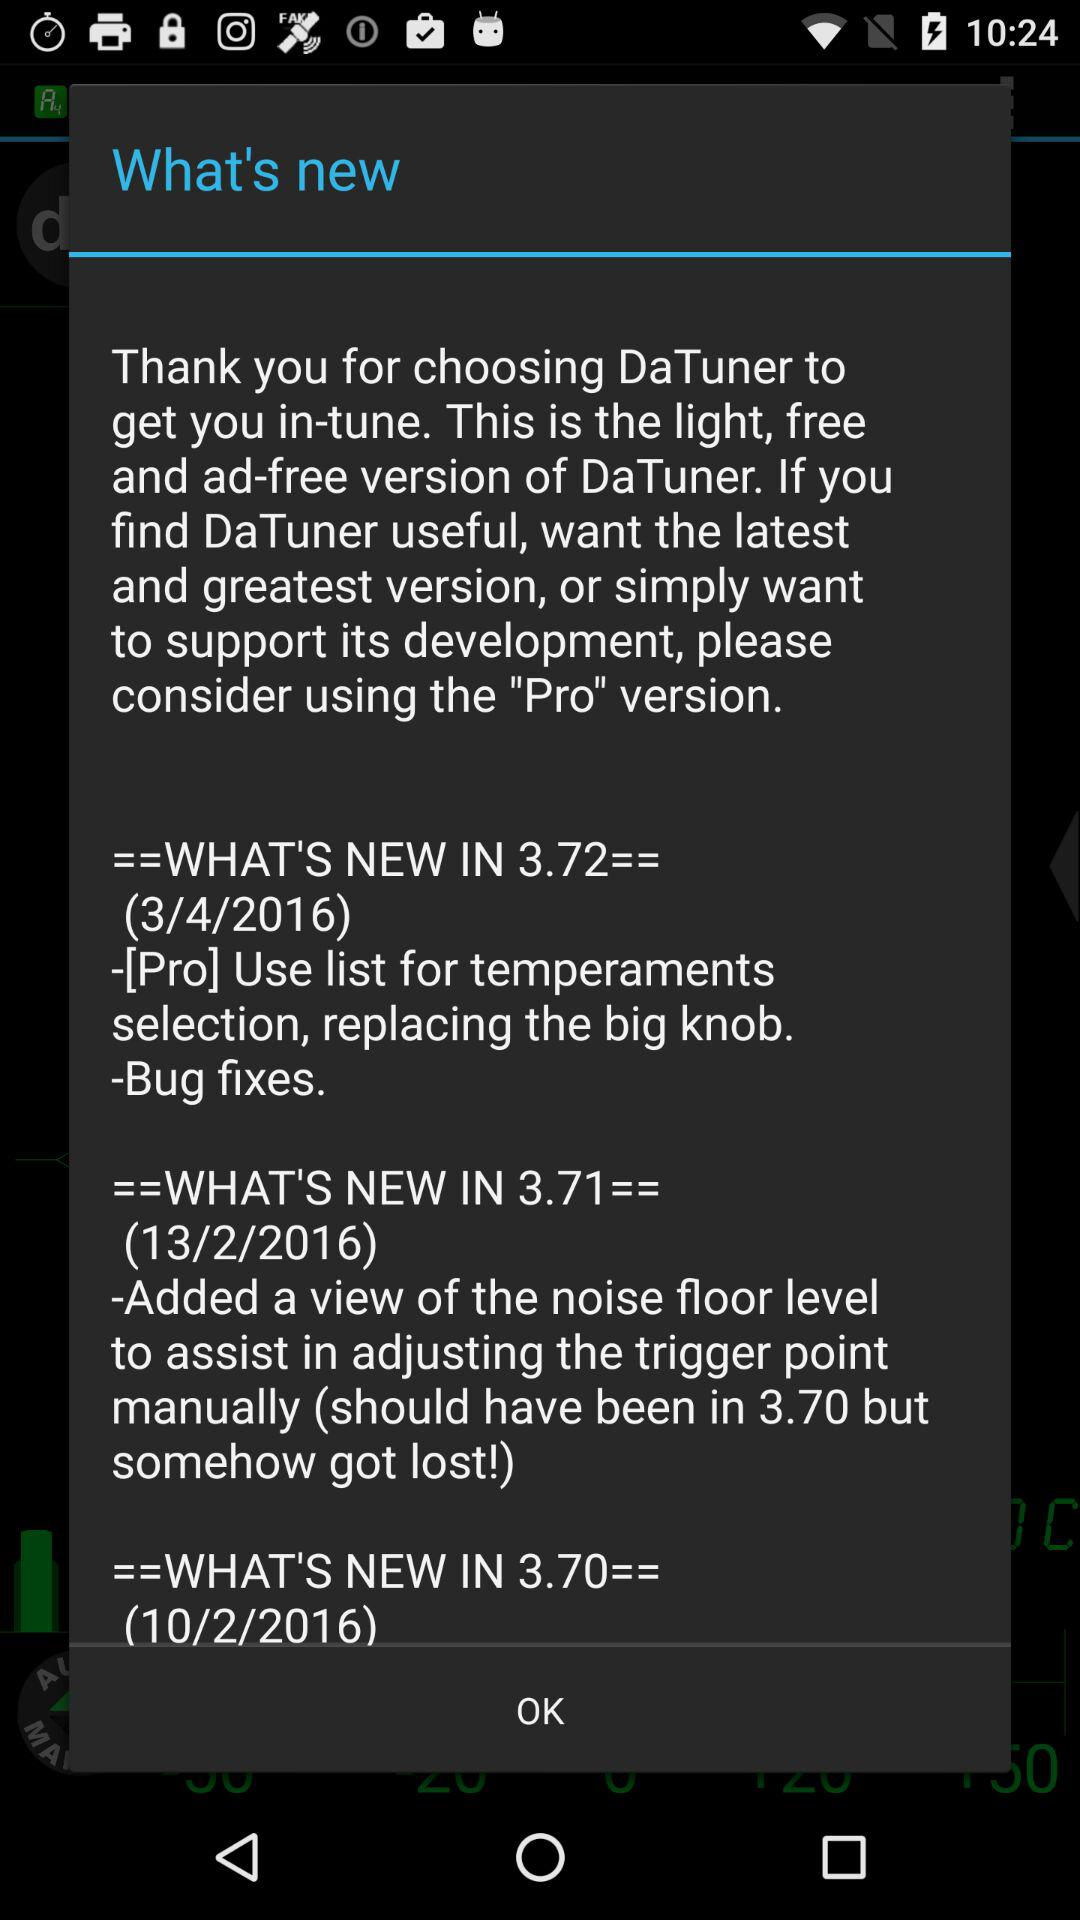What is the version of the application? The versions of the application are 3.72, 3.71 and 3.70. 